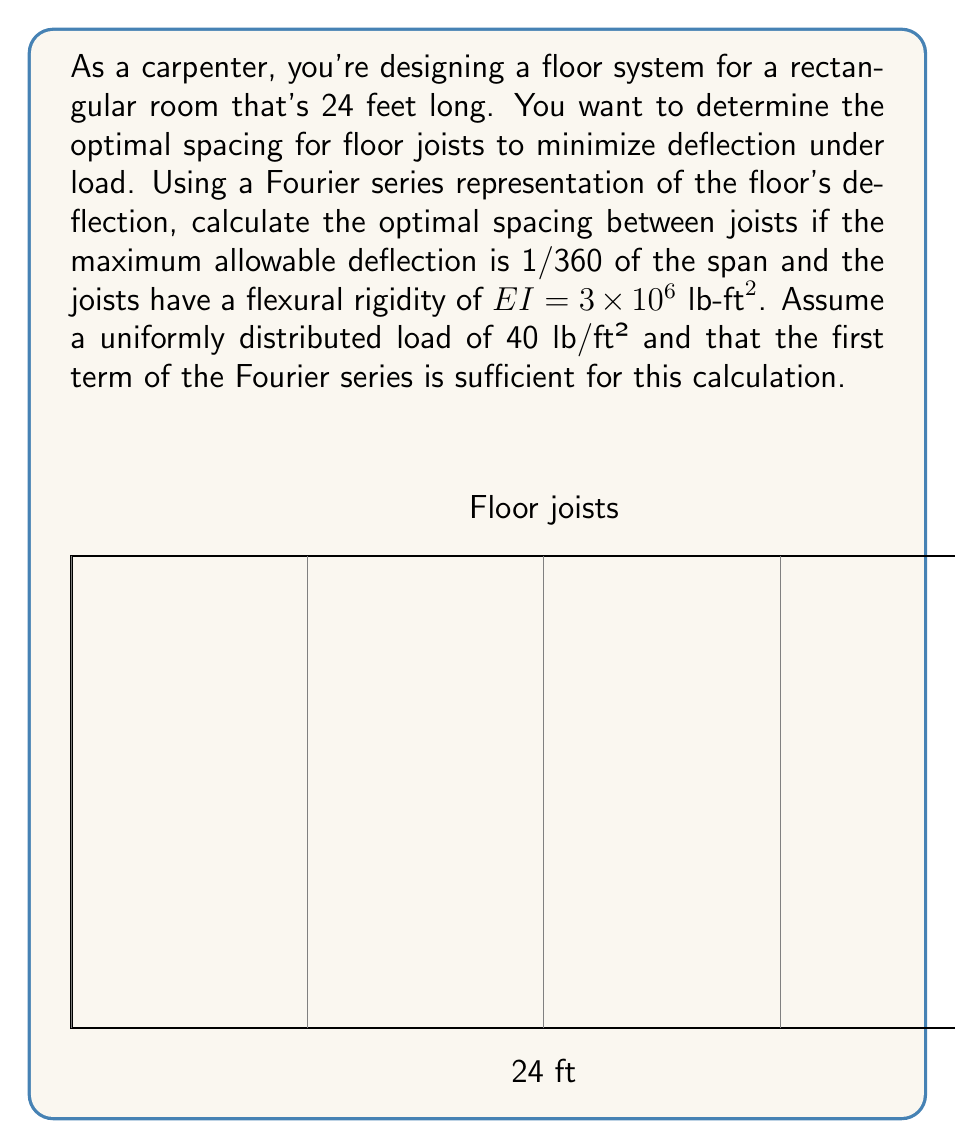Solve this math problem. Let's approach this step-by-step:

1) The deflection of a simply supported beam under uniform load can be represented by a Fourier series. The first term of this series is:

   $$w(x) = \frac{16w_0L^4}{\pi^5EI} \sin(\frac{\pi x}{L})$$

   where $w_0$ is the uniform load per unit length, $L$ is the span, and $EI$ is the flexural rigidity.

2) The maximum deflection occurs at the center of the span $(x = L/2)$, where $\sin(\frac{\pi x}{L}) = 1$:

   $$w_{max} = \frac{16w_0L^4}{\pi^5EI}$$

3) We're given:
   - $L = 24 \text{ ft}$
   - $EI = 3 \times 10^6 \text{ lb-ft}^2$
   - $w_0 = 40 \text{ lb/ft}^2$ (we need to multiply this by the joist spacing $s$ to get load per unit length)
   - Maximum allowable deflection = $L/360 = 24/360 = 1/15 \text{ ft}$

4) Substituting these into our equation:

   $$\frac{1}{15} = \frac{16(40s)(24)^4}{\pi^5(3 \times 10^6)}$$

5) Solving for $s$:

   $$s = \frac{\pi^5(3 \times 10^6)}{15 \times 16 \times 40 \times 24^4} \approx 1.64 \text{ ft}$$

6) Convert to inches for practical use:

   $$s \approx 1.64 \times 12 \approx 19.7 \text{ inches}$$

7) In practice, we would round this down to the nearest standard joist spacing, which is 16 inches.
Answer: 16 inches 